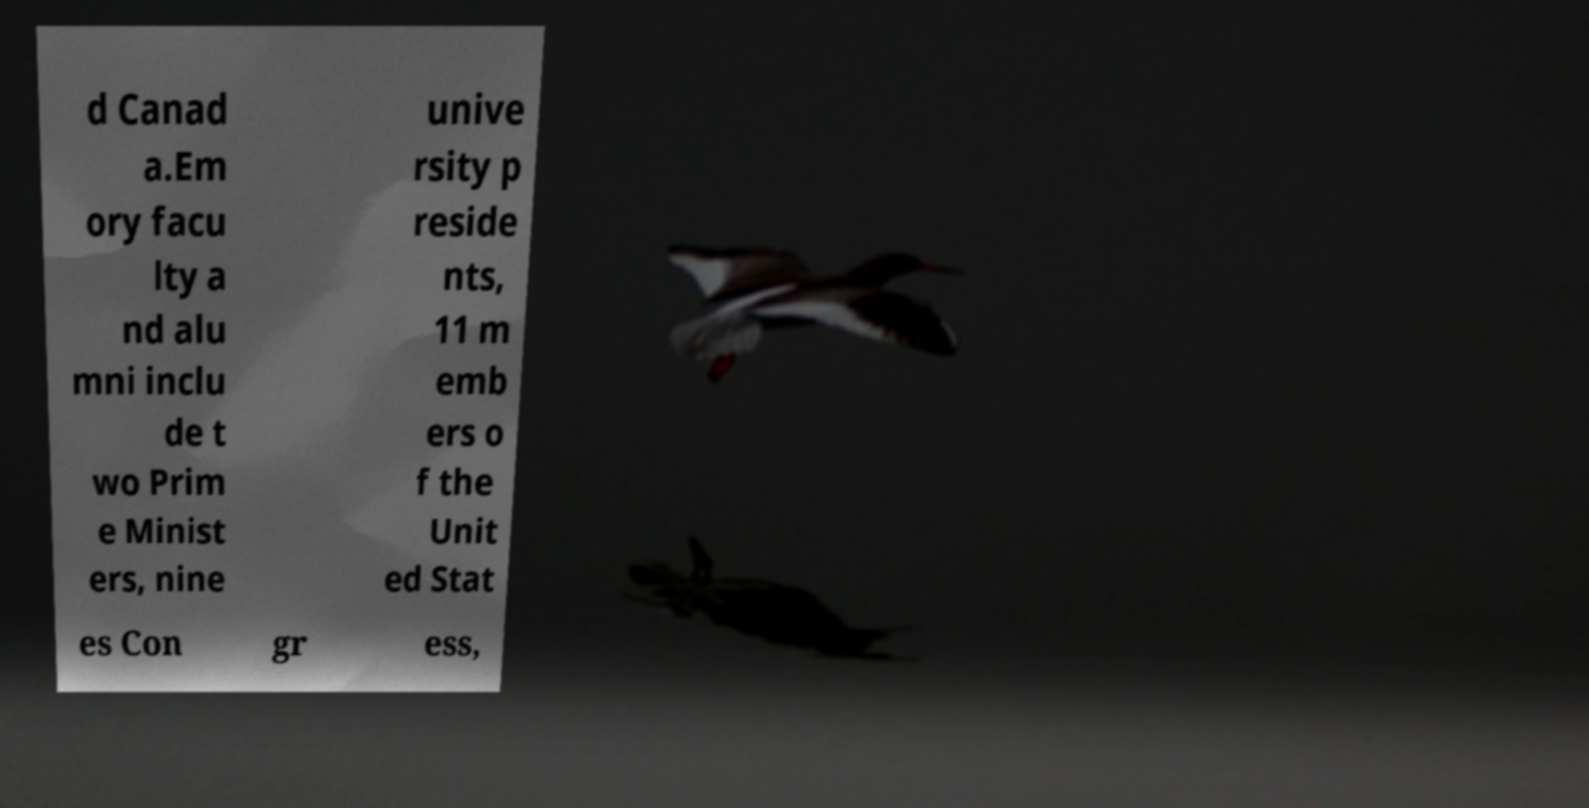Could you assist in decoding the text presented in this image and type it out clearly? d Canad a.Em ory facu lty a nd alu mni inclu de t wo Prim e Minist ers, nine unive rsity p reside nts, 11 m emb ers o f the Unit ed Stat es Con gr ess, 